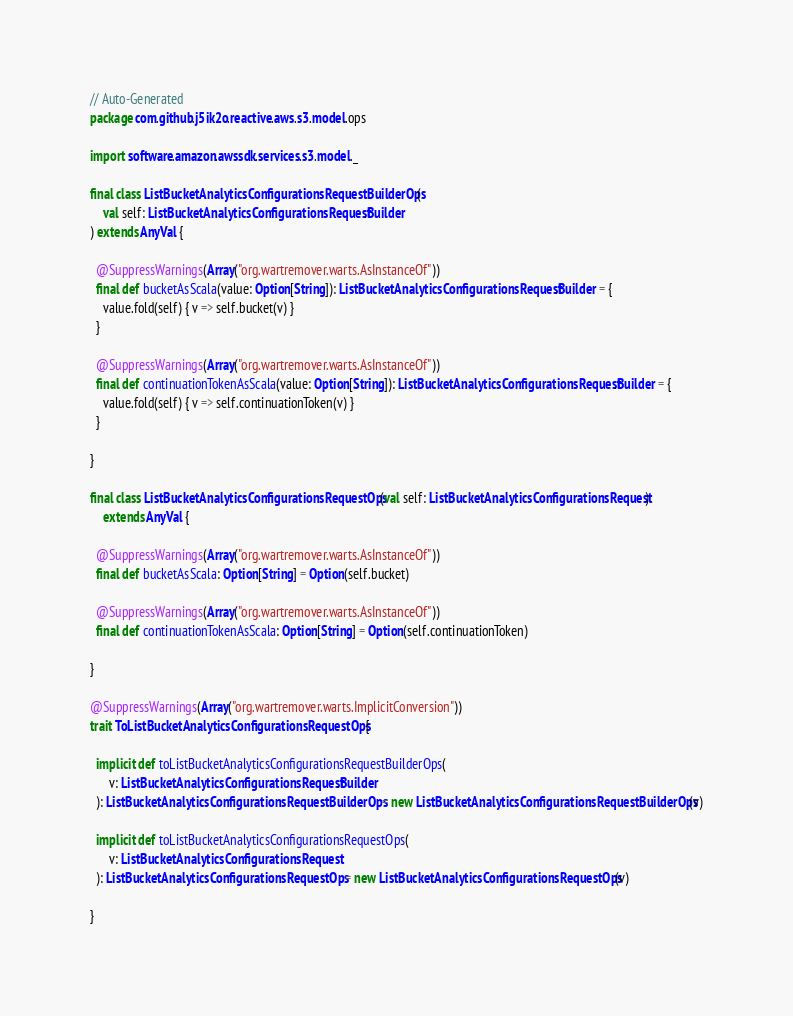<code> <loc_0><loc_0><loc_500><loc_500><_Scala_>// Auto-Generated
package com.github.j5ik2o.reactive.aws.s3.model.ops

import software.amazon.awssdk.services.s3.model._

final class ListBucketAnalyticsConfigurationsRequestBuilderOps(
    val self: ListBucketAnalyticsConfigurationsRequest.Builder
) extends AnyVal {

  @SuppressWarnings(Array("org.wartremover.warts.AsInstanceOf"))
  final def bucketAsScala(value: Option[String]): ListBucketAnalyticsConfigurationsRequest.Builder = {
    value.fold(self) { v => self.bucket(v) }
  }

  @SuppressWarnings(Array("org.wartremover.warts.AsInstanceOf"))
  final def continuationTokenAsScala(value: Option[String]): ListBucketAnalyticsConfigurationsRequest.Builder = {
    value.fold(self) { v => self.continuationToken(v) }
  }

}

final class ListBucketAnalyticsConfigurationsRequestOps(val self: ListBucketAnalyticsConfigurationsRequest)
    extends AnyVal {

  @SuppressWarnings(Array("org.wartremover.warts.AsInstanceOf"))
  final def bucketAsScala: Option[String] = Option(self.bucket)

  @SuppressWarnings(Array("org.wartremover.warts.AsInstanceOf"))
  final def continuationTokenAsScala: Option[String] = Option(self.continuationToken)

}

@SuppressWarnings(Array("org.wartremover.warts.ImplicitConversion"))
trait ToListBucketAnalyticsConfigurationsRequestOps {

  implicit def toListBucketAnalyticsConfigurationsRequestBuilderOps(
      v: ListBucketAnalyticsConfigurationsRequest.Builder
  ): ListBucketAnalyticsConfigurationsRequestBuilderOps = new ListBucketAnalyticsConfigurationsRequestBuilderOps(v)

  implicit def toListBucketAnalyticsConfigurationsRequestOps(
      v: ListBucketAnalyticsConfigurationsRequest
  ): ListBucketAnalyticsConfigurationsRequestOps = new ListBucketAnalyticsConfigurationsRequestOps(v)

}
</code> 